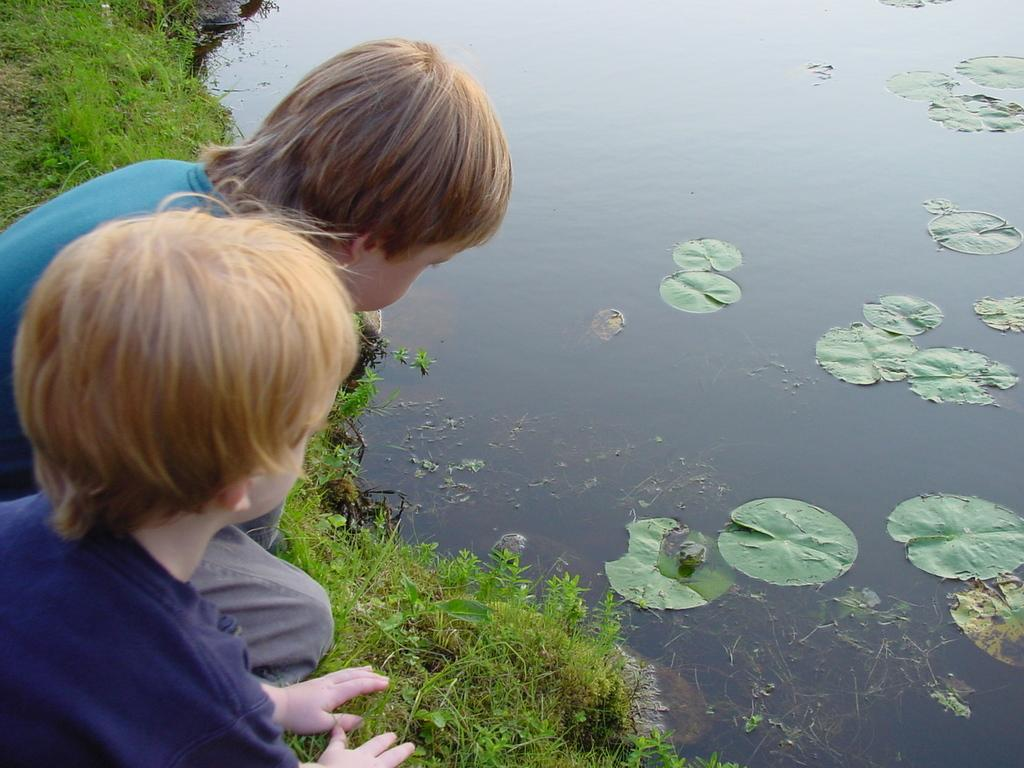What type of vegetation can be seen in the image? There is grass in the image. What else can be seen besides grass? There is water and leaves in the image. Are there any animals visible in the image? Yes, there are frogs in the image. Where are the two people sitting in the image? The two people are sitting on the left side of the image. What type of teeth does the mom have in the image? There is no mom present in the image, so it is not possible to determine what type of teeth she might have. 